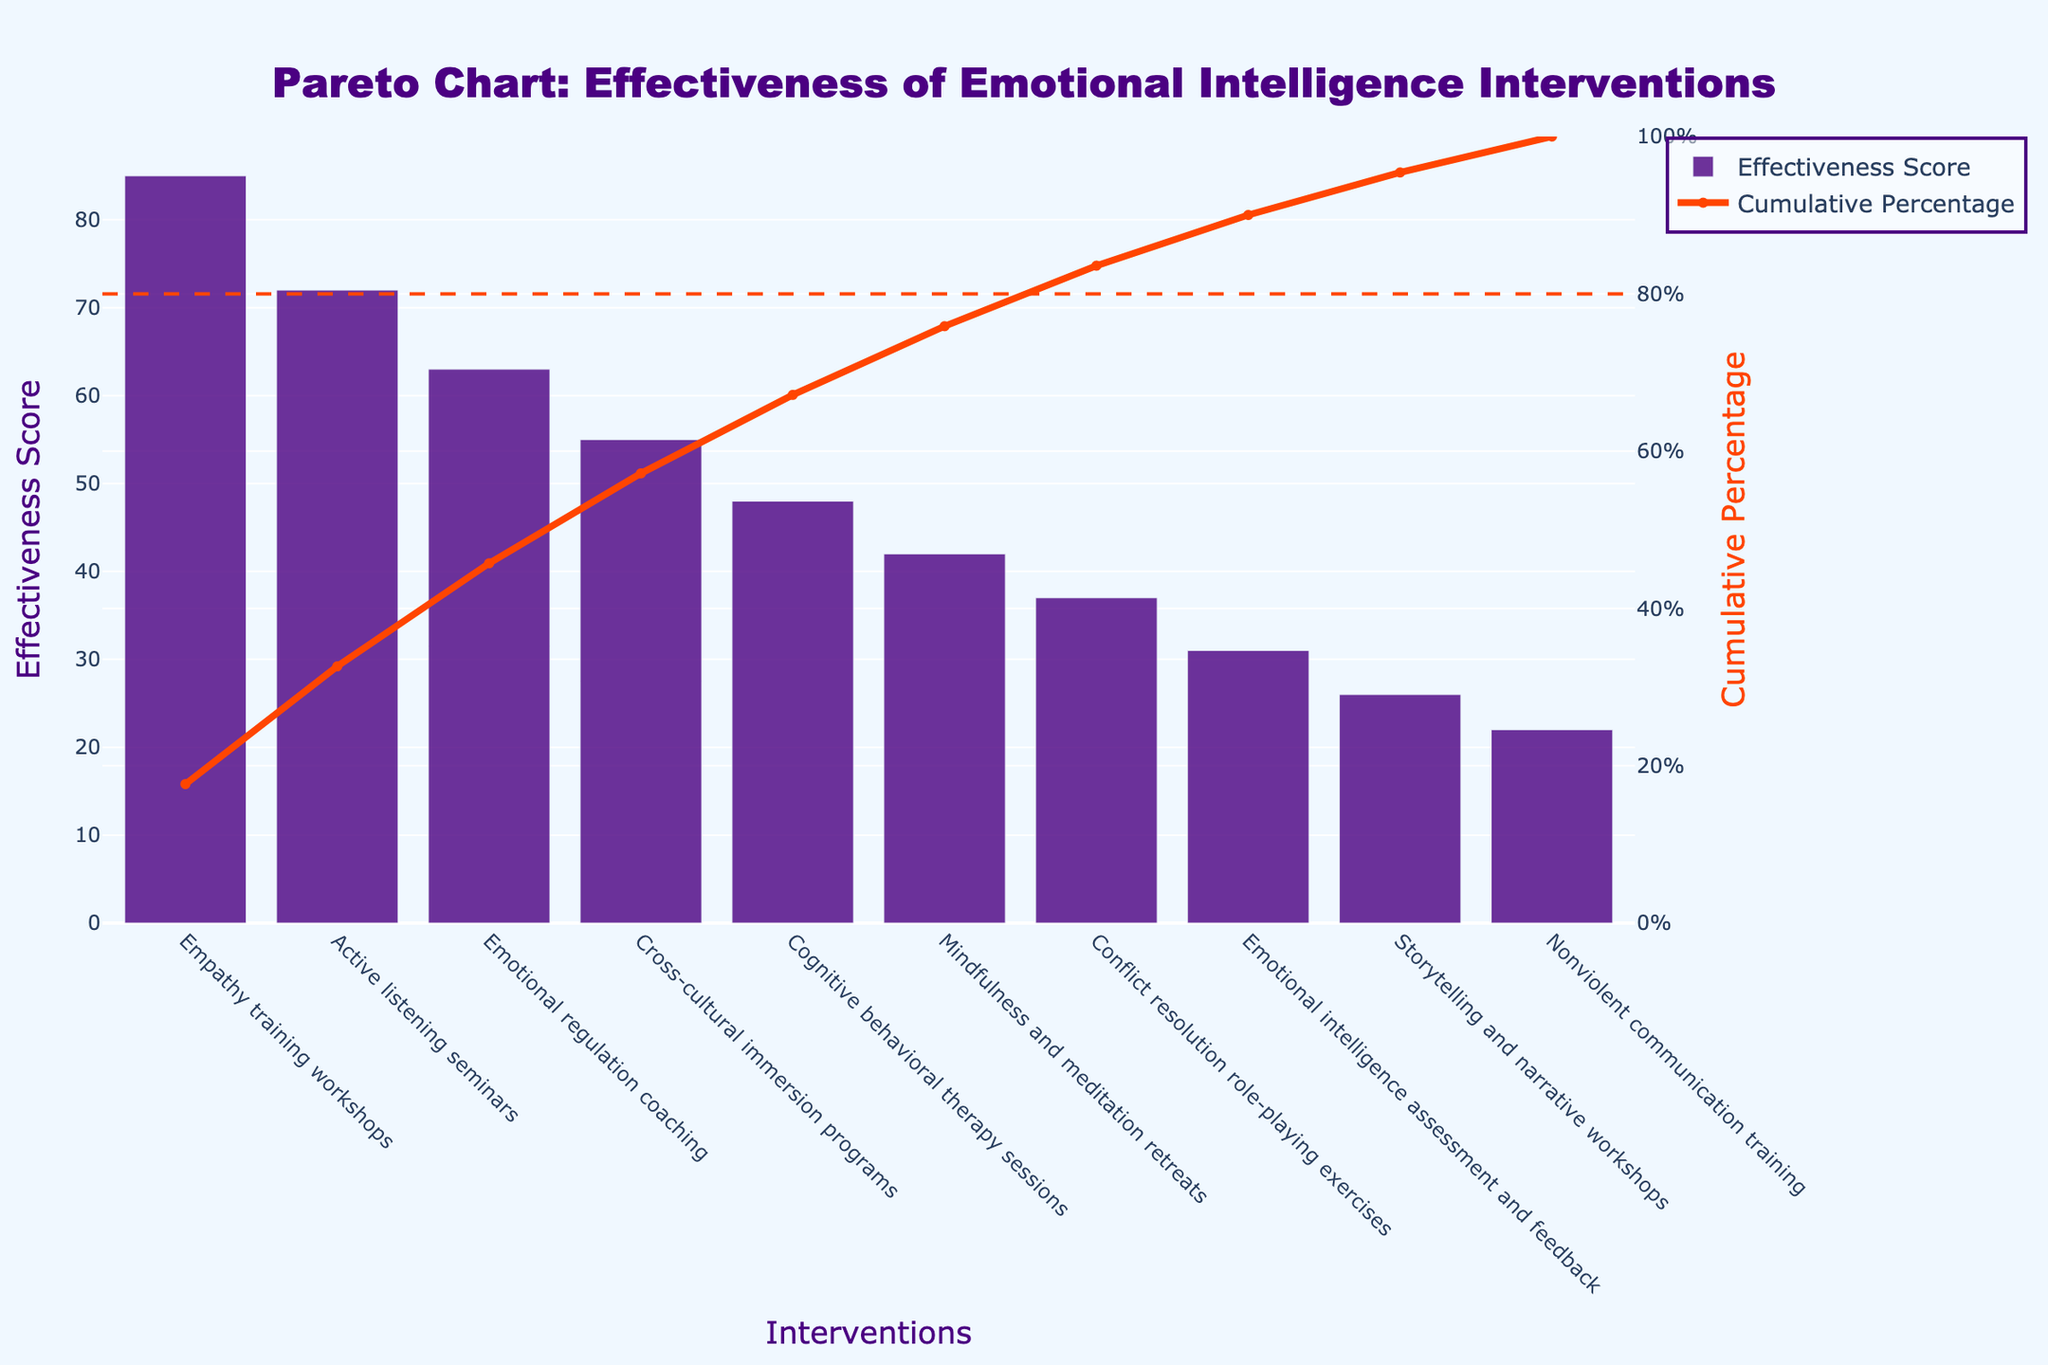What is the title of the chart? The title of the chart is usually located at the top of the figure. Here, it reads, "Pareto Chart: Effectiveness of Emotional Intelligence Interventions."
Answer: Pareto Chart: Effectiveness of Emotional Intelligence Interventions Which intervention has the highest effectiveness score? By looking at the height of the bars, the tallest bar corresponds to the intervention with the highest effectiveness score. Empathy training workshops is the tallest bar.
Answer: Empathy training workshops What are the units of the effectiveness score axis? The y-axis on the left-hand side represents the effectiveness score and is labeled accordingly in the chart.
Answer: Effectiveness Score What percentage of total effectiveness is covered by Empathy training workshops and Active listening seminars combined? First, extract the effectiveness scores: Empathy training workshops (85) and Active listening seminars (72). Combined, the score is 157. The total sum of all scores is the cumulative value of the last bar: 451. The combined percentage is (157 / 451) * 100%.
Answer: 34.81% What intervention marks the 80% cumulative percentage line? Follow the cumulative percentage line in orange up to the dashed horizontal line at 80%. The intervention that aligns vertically is Emotional regulation coaching.
Answer: Emotional regulation coaching How many interventions have an effectiveness score equal to or greater than 50? Identify bars with heights equal to or above the 50 mark on the y-axis. These interventions include Empathy training workshops, Active listening seminars, Emotional regulation coaching, and Cross-cultural immersion programs.
Answer: 4 Which intervention has the lowest effectiveness score? The shortest bar in the figure corresponds to the intervention with the lowest effectiveness score. Nonviolent communication training has the shortest bar.
Answer: Nonviolent communication training How much more effective is Cognitive behavioral therapy sessions compared to Nonviolent communication training? The effectiveness score for Cognitive behavioral therapy sessions (48) minus the score for Nonviolent communication training (22) is calculated to find the difference.
Answer: 26 What is the cumulative percentage after the top 3 interventions? The sum of the effectiveness scores of the top 3 interventions (Empathy training workshops, Active listening seminars, Emotional regulation coaching) is 85 + 72 + 63 = 220. The cumulative percentage is (220 / 451) * 100%.
Answer: 48.78% How does the effectiveness score of Storytelling and narrative workshops compare to that of Mindfulness and meditation retreats? Compare the heights of the bars for both interventions. Mindfulness and meditation retreats has a higher effectiveness score (42) compared to Storytelling and narrative workshops (26).
Answer: Mindfulness and meditation retreats is higher 